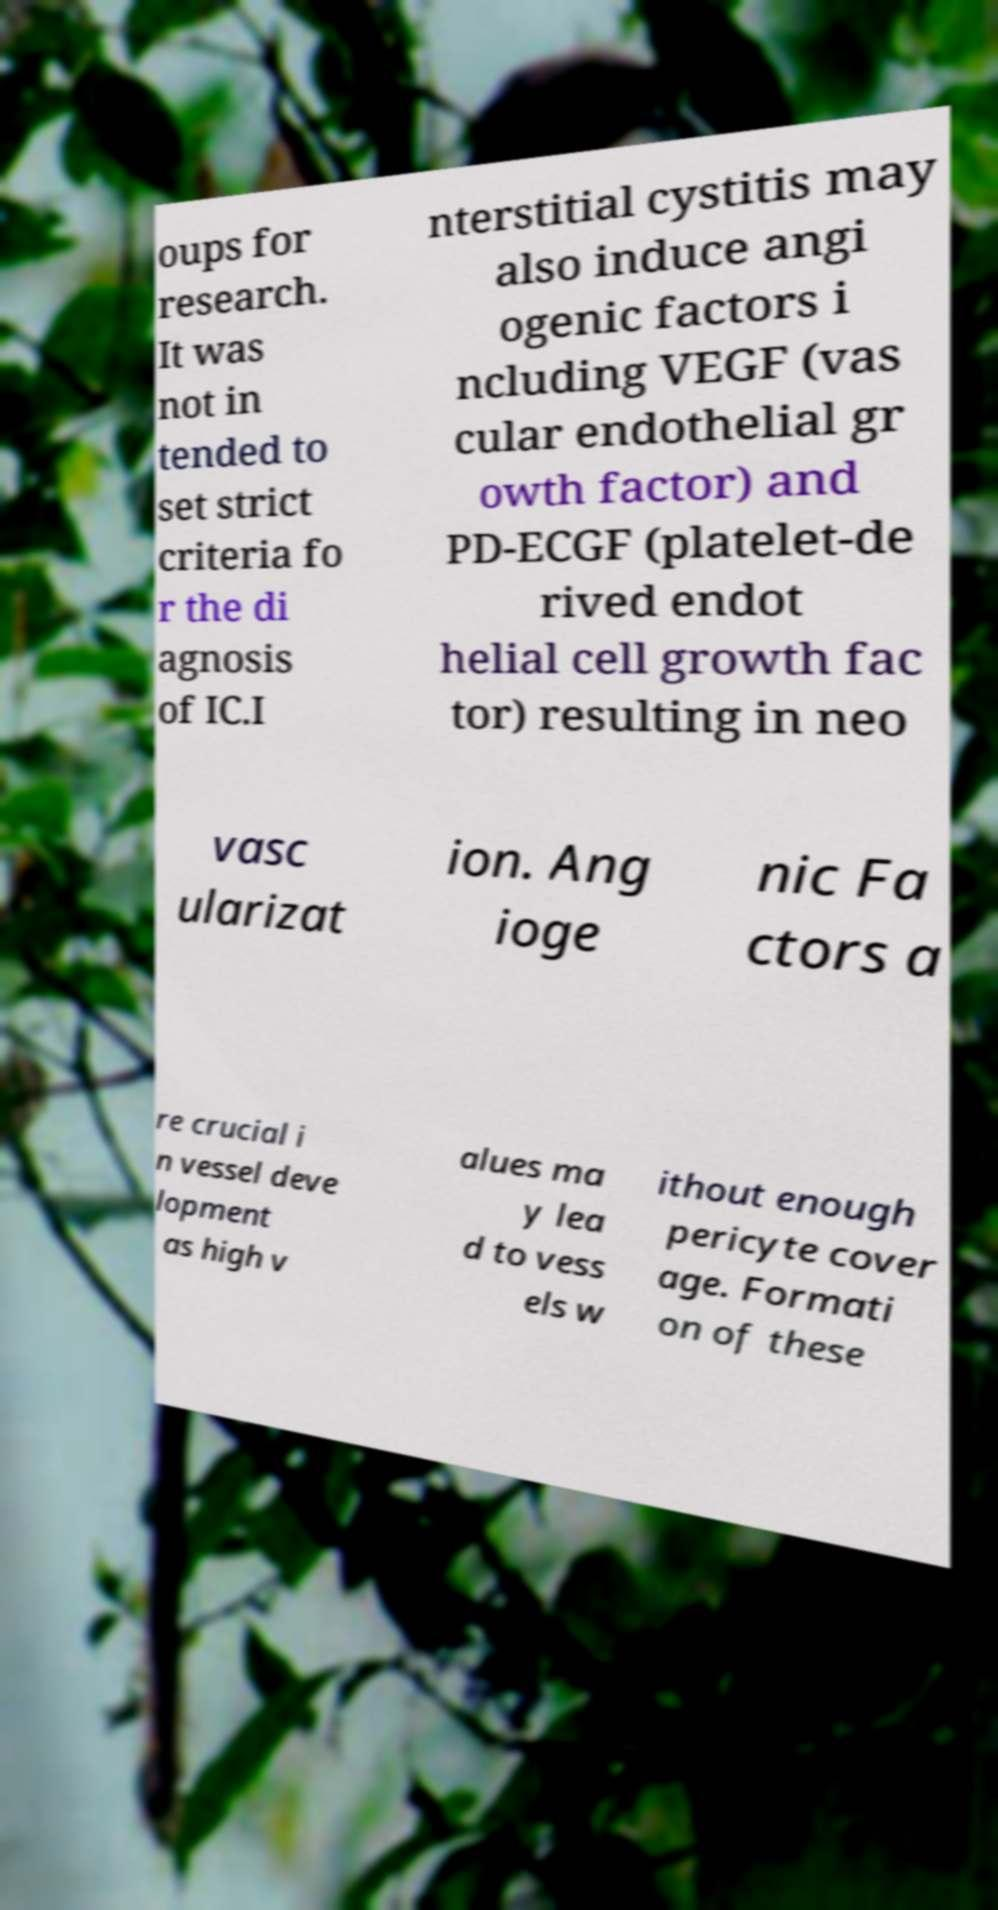For documentation purposes, I need the text within this image transcribed. Could you provide that? oups for research. It was not in tended to set strict criteria fo r the di agnosis of IC.I nterstitial cystitis may also induce angi ogenic factors i ncluding VEGF (vas cular endothelial gr owth factor) and PD-ECGF (platelet-de rived endot helial cell growth fac tor) resulting in neo vasc ularizat ion. Ang ioge nic Fa ctors a re crucial i n vessel deve lopment as high v alues ma y lea d to vess els w ithout enough pericyte cover age. Formati on of these 